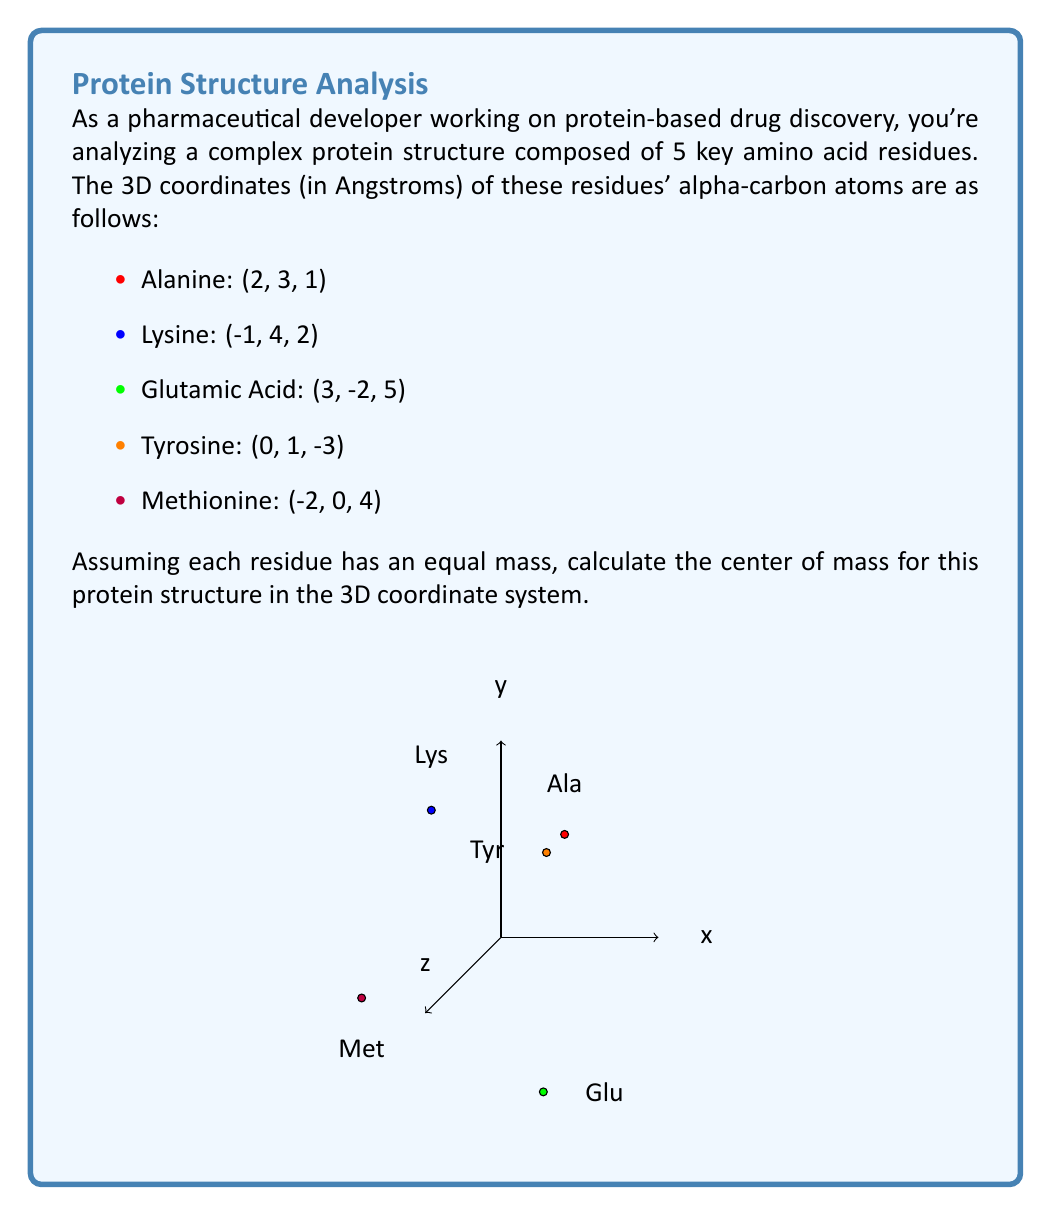Give your solution to this math problem. To find the center of mass for this protein structure, we need to calculate the average position of all the residues in each dimension (x, y, and z). Since each residue is assumed to have equal mass, we can simply take the arithmetic mean of the coordinates.

Let's break it down step-by-step:

1. Sum up the x-coordinates:
   $x_{sum} = 2 + (-1) + 3 + 0 + (-2) = 2$

2. Sum up the y-coordinates:
   $y_{sum} = 3 + 4 + (-2) + 1 + 0 = 6$

3. Sum up the z-coordinates:
   $z_{sum} = 1 + 2 + 5 + (-3) + 4 = 9$

4. Calculate the average for each dimension by dividing the sum by the number of residues (5):

   $x_{center} = \frac{x_{sum}}{5} = \frac{2}{5} = 0.4$

   $y_{center} = \frac{y_{sum}}{5} = \frac{6}{5} = 1.2$

   $z_{center} = \frac{z_{sum}}{5} = \frac{9}{5} = 1.8$

5. The center of mass is the point with these average coordinates:
   $(\frac{2}{5}, \frac{6}{5}, \frac{9}{5})$ or $(0.4, 1.2, 1.8)$

This point represents the average position of the protein structure in 3D space, which is crucial for understanding its overall shape and potential interactions in drug discovery applications.
Answer: $(0.4, 1.2, 1.8)$ 